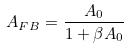Convert formula to latex. <formula><loc_0><loc_0><loc_500><loc_500>A _ { F B } = \frac { A _ { 0 } } { 1 + \beta A _ { 0 } }</formula> 